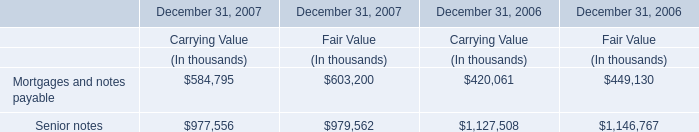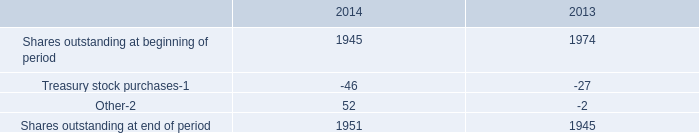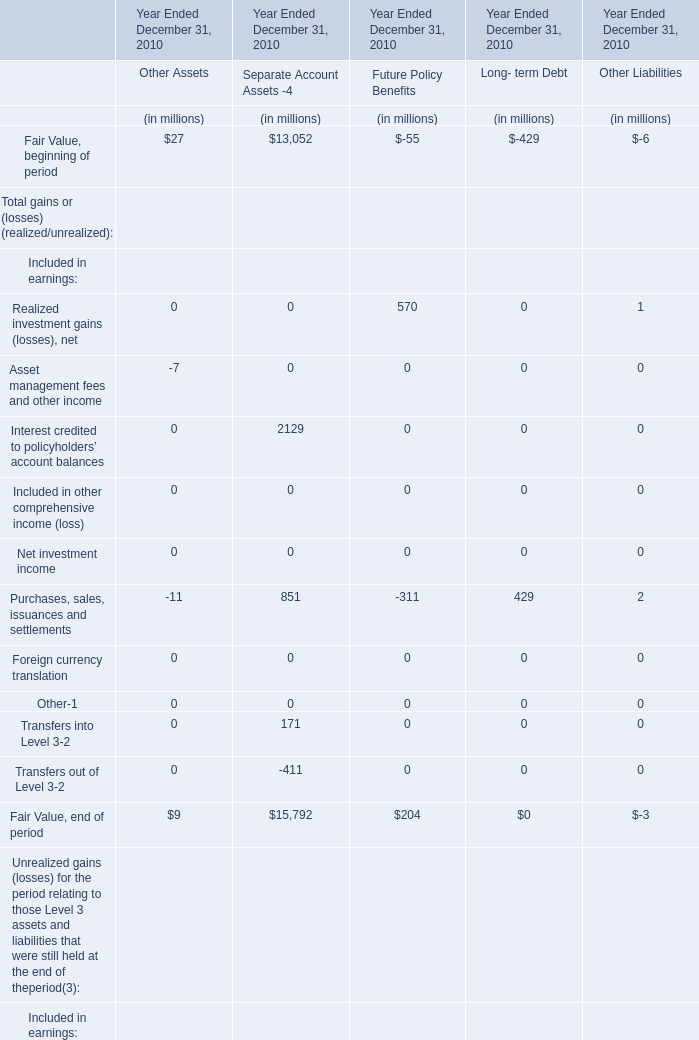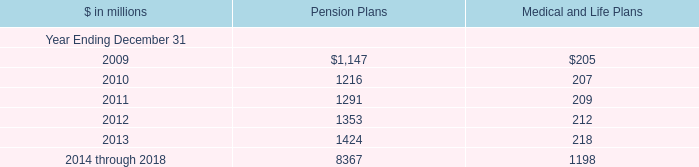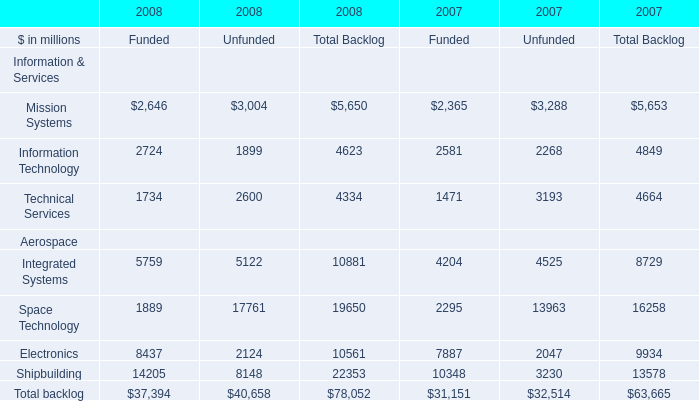What was the Fair Value, end of period for Future Policy Benefits for Year Ended December 31, 2010? (in million) 
Answer: 204. 